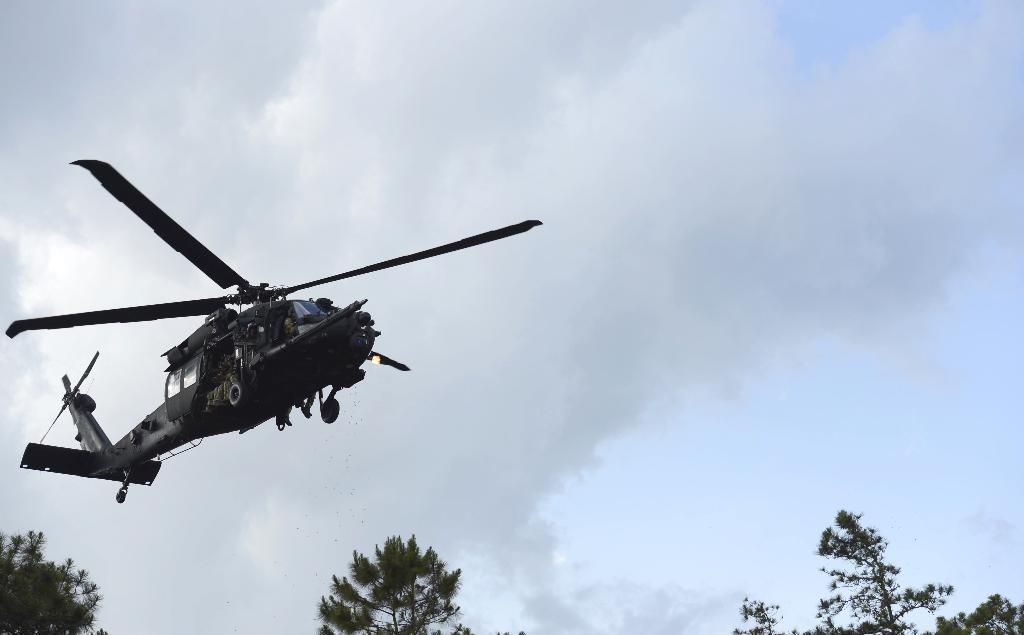Please provide a concise description of this image. In the picture I can see a helicopter is flying in the air. Here I can see trees and the cloudy sky in the background. 